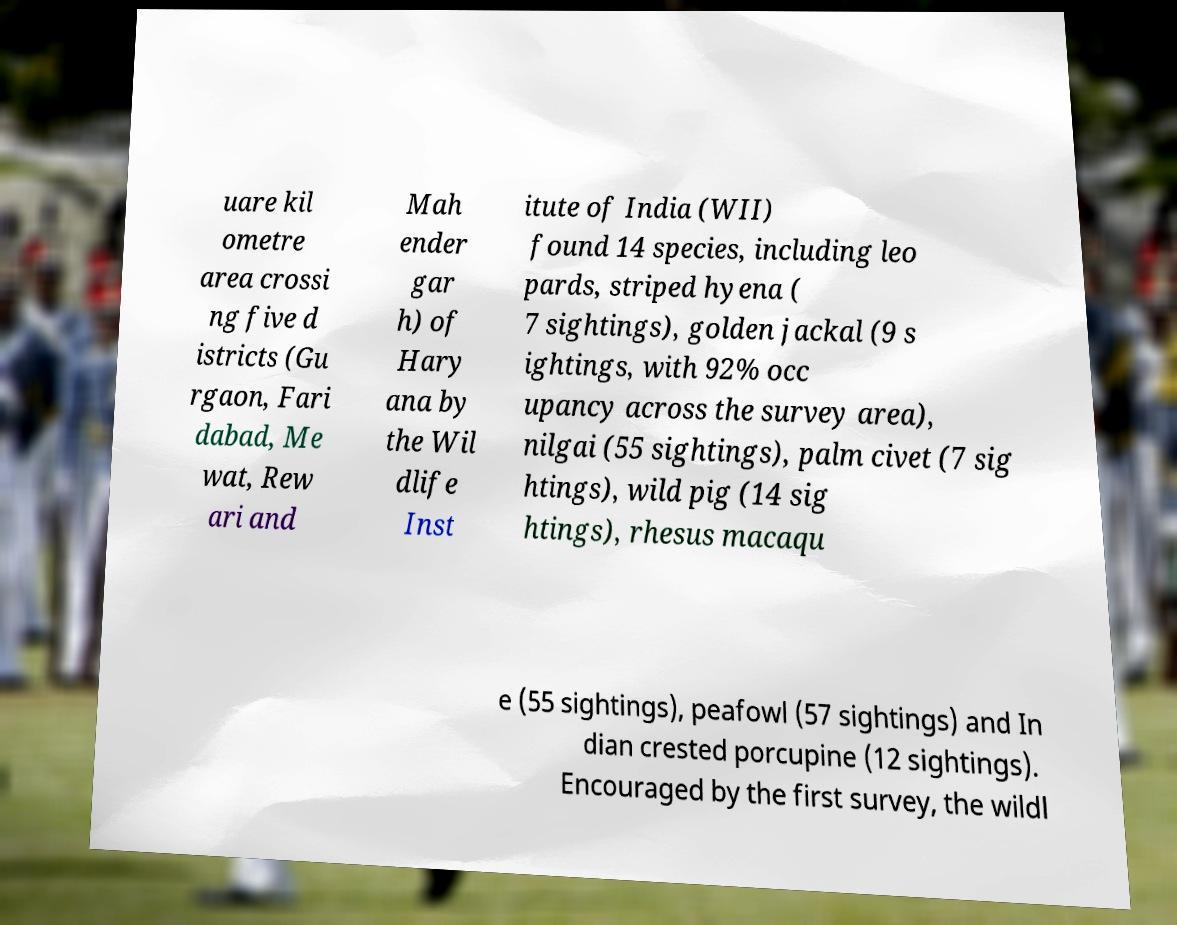Please read and relay the text visible in this image. What does it say? uare kil ometre area crossi ng five d istricts (Gu rgaon, Fari dabad, Me wat, Rew ari and Mah ender gar h) of Hary ana by the Wil dlife Inst itute of India (WII) found 14 species, including leo pards, striped hyena ( 7 sightings), golden jackal (9 s ightings, with 92% occ upancy across the survey area), nilgai (55 sightings), palm civet (7 sig htings), wild pig (14 sig htings), rhesus macaqu e (55 sightings), peafowl (57 sightings) and In dian crested porcupine (12 sightings). Encouraged by the first survey, the wildl 